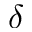<formula> <loc_0><loc_0><loc_500><loc_500>\delta</formula> 